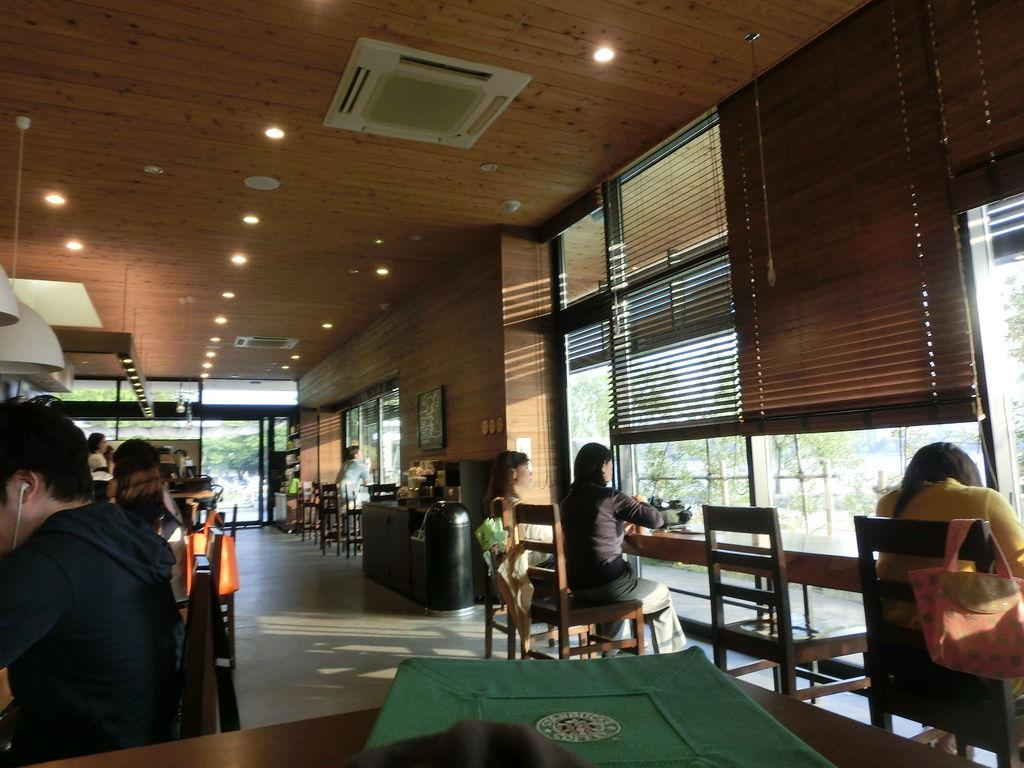What type of establishment is shown in the image? The image depicts a restaurant. What are the people in the image doing? People are seated on chairs in the restaurant. What feature can be seen on the windows in the restaurant? There are blinds on the windows in the restaurant. What type of system is being used by the kitty to light the match in the image? There is no kitty or match present in the image, so this question cannot be answered. 